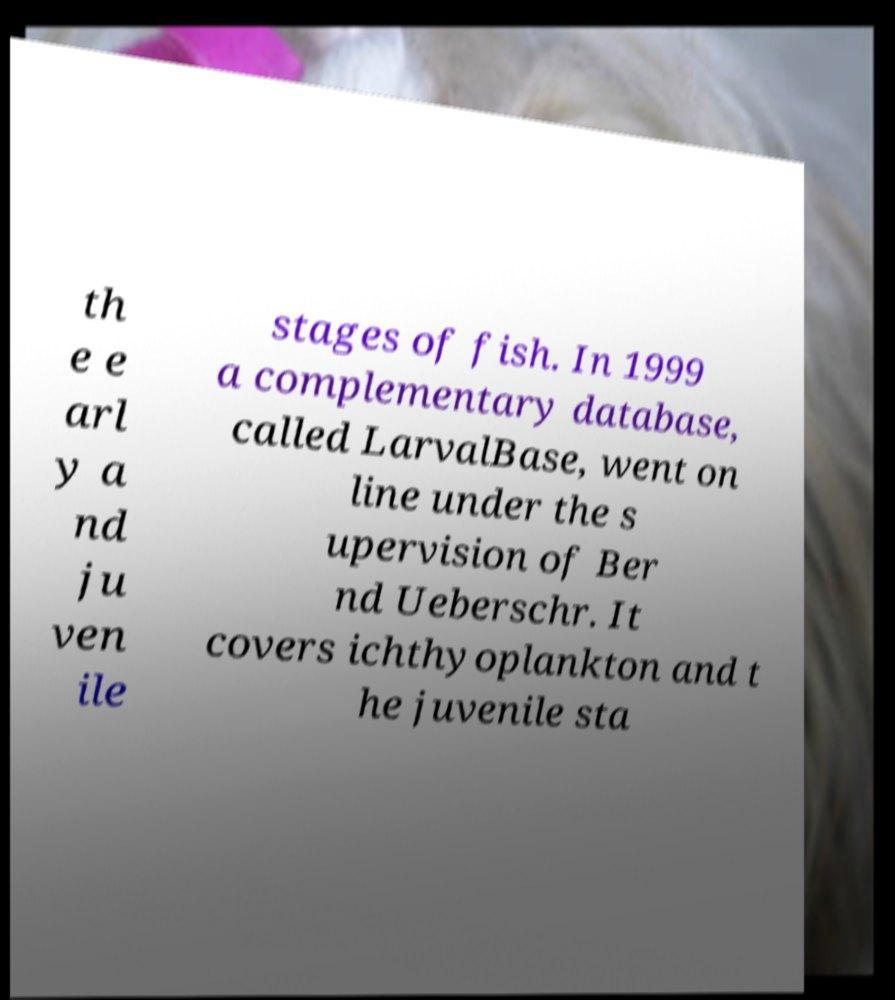There's text embedded in this image that I need extracted. Can you transcribe it verbatim? th e e arl y a nd ju ven ile stages of fish. In 1999 a complementary database, called LarvalBase, went on line under the s upervision of Ber nd Ueberschr. It covers ichthyoplankton and t he juvenile sta 